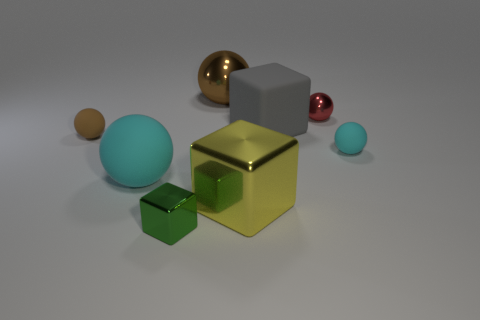Is there a red ball of the same size as the gray cube?
Your answer should be compact. No. What number of objects are green metallic things or big rubber cylinders?
Give a very brief answer. 1. Does the rubber sphere in front of the tiny cyan matte thing have the same size as the cube that is right of the large yellow object?
Provide a succinct answer. Yes. Is there a large cyan matte object that has the same shape as the tiny green object?
Ensure brevity in your answer.  No. Are there fewer tiny brown matte balls that are to the right of the yellow object than big blue rubber blocks?
Give a very brief answer. No. Is the gray thing the same shape as the green metal thing?
Give a very brief answer. Yes. There is a cyan sphere right of the big shiny block; what is its size?
Offer a very short reply. Small. What is the size of the brown object that is made of the same material as the gray object?
Offer a terse response. Small. Are there fewer tiny brown rubber things than tiny cyan blocks?
Your answer should be very brief. No. What is the material of the cube that is the same size as the brown rubber sphere?
Make the answer very short. Metal. 